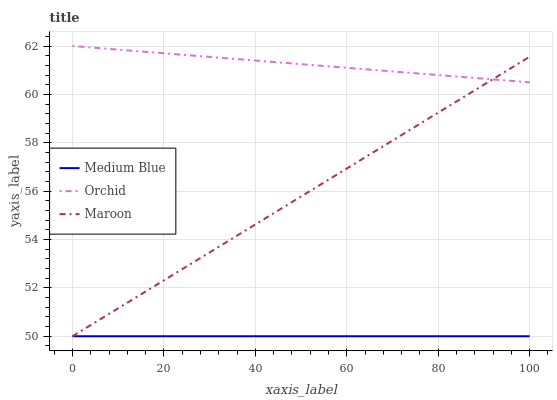Does Medium Blue have the minimum area under the curve?
Answer yes or no. Yes. Does Orchid have the maximum area under the curve?
Answer yes or no. Yes. Does Maroon have the minimum area under the curve?
Answer yes or no. No. Does Maroon have the maximum area under the curve?
Answer yes or no. No. Is Medium Blue the smoothest?
Answer yes or no. Yes. Is Orchid the roughest?
Answer yes or no. Yes. Is Orchid the smoothest?
Answer yes or no. No. Is Maroon the roughest?
Answer yes or no. No. Does Medium Blue have the lowest value?
Answer yes or no. Yes. Does Orchid have the lowest value?
Answer yes or no. No. Does Orchid have the highest value?
Answer yes or no. Yes. Does Maroon have the highest value?
Answer yes or no. No. Is Medium Blue less than Orchid?
Answer yes or no. Yes. Is Orchid greater than Medium Blue?
Answer yes or no. Yes. Does Maroon intersect Orchid?
Answer yes or no. Yes. Is Maroon less than Orchid?
Answer yes or no. No. Is Maroon greater than Orchid?
Answer yes or no. No. Does Medium Blue intersect Orchid?
Answer yes or no. No. 